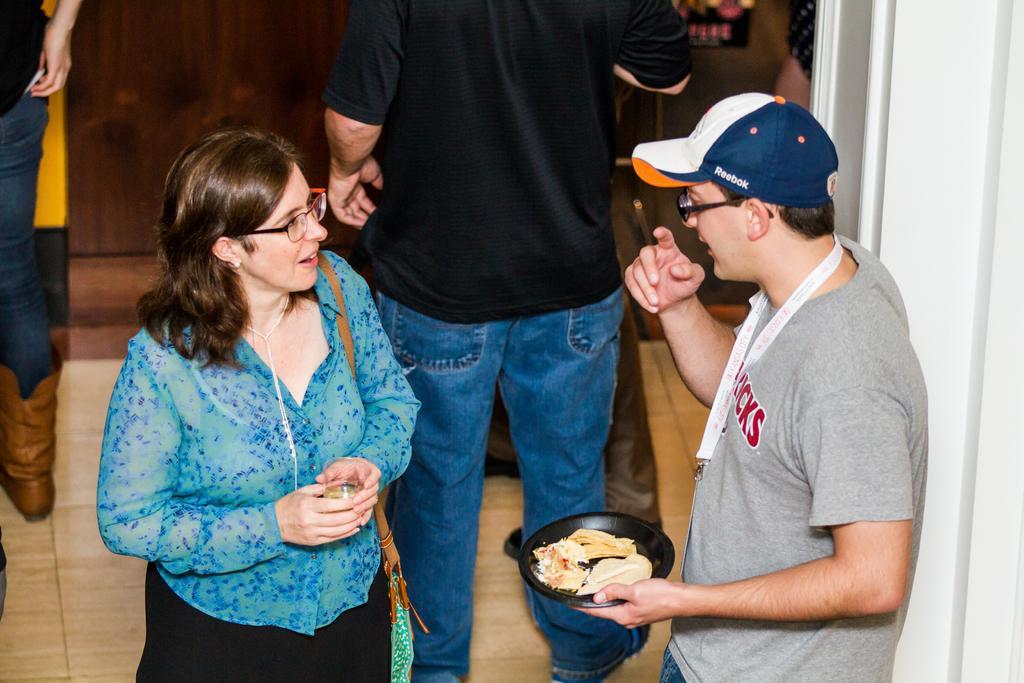Describe this image in one or two sentences. In this image I can see the group of people with different color dresses. I can see one person with the cap and two people with the specs. One person holding the plate with food and another person holding the glass. In the background I can see the wooden wall. 